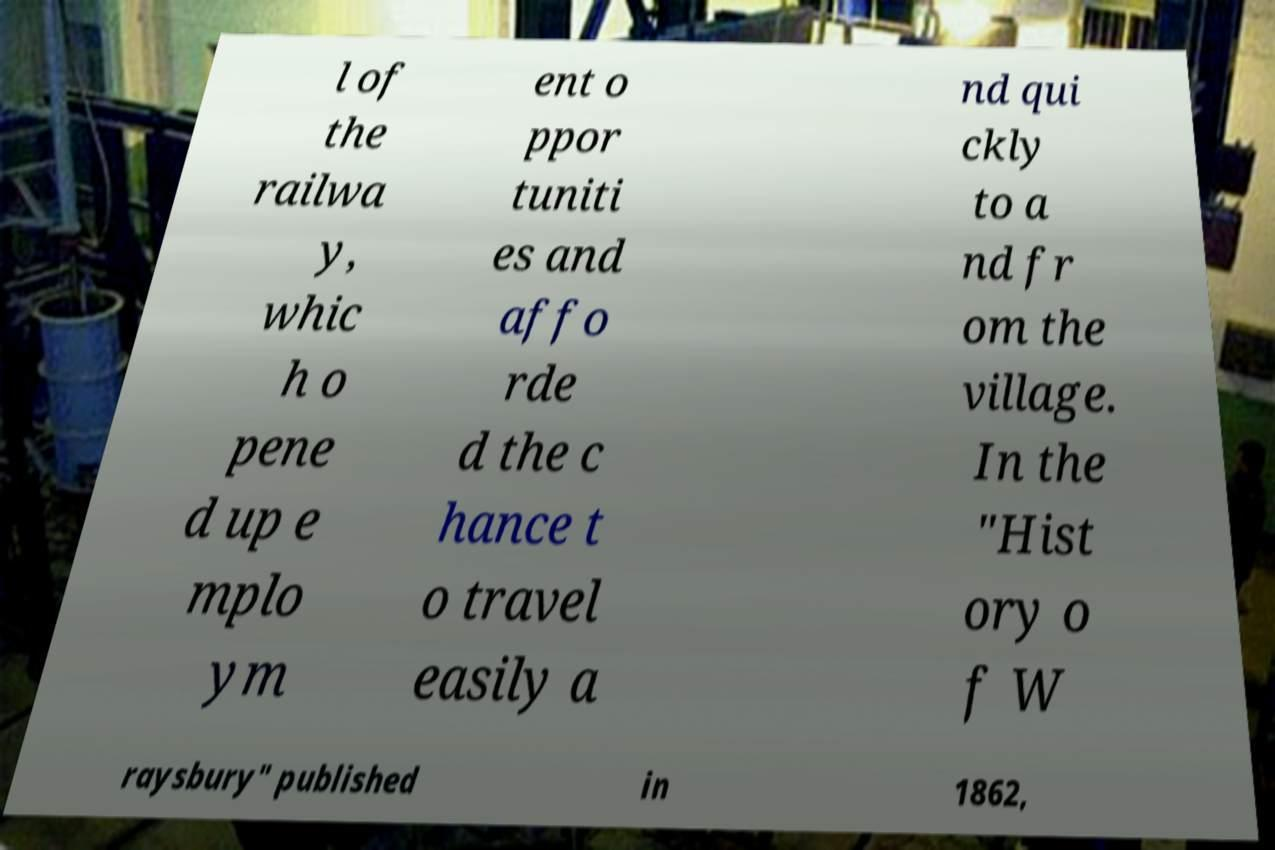Please identify and transcribe the text found in this image. l of the railwa y, whic h o pene d up e mplo ym ent o ppor tuniti es and affo rde d the c hance t o travel easily a nd qui ckly to a nd fr om the village. In the "Hist ory o f W raysbury" published in 1862, 